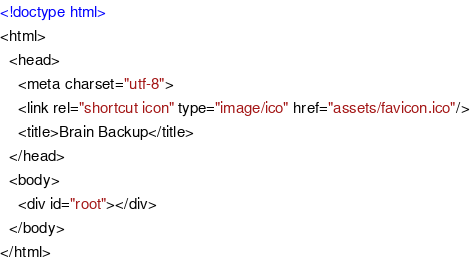Convert code to text. <code><loc_0><loc_0><loc_500><loc_500><_HTML_><!doctype html>
<html>
  <head>
    <meta charset="utf-8">
    <link rel="shortcut icon" type="image/ico" href="assets/favicon.ico"/>
    <title>Brain Backup</title>
  </head>
  <body>
    <div id="root"></div>
  </body>
</html>
</code> 